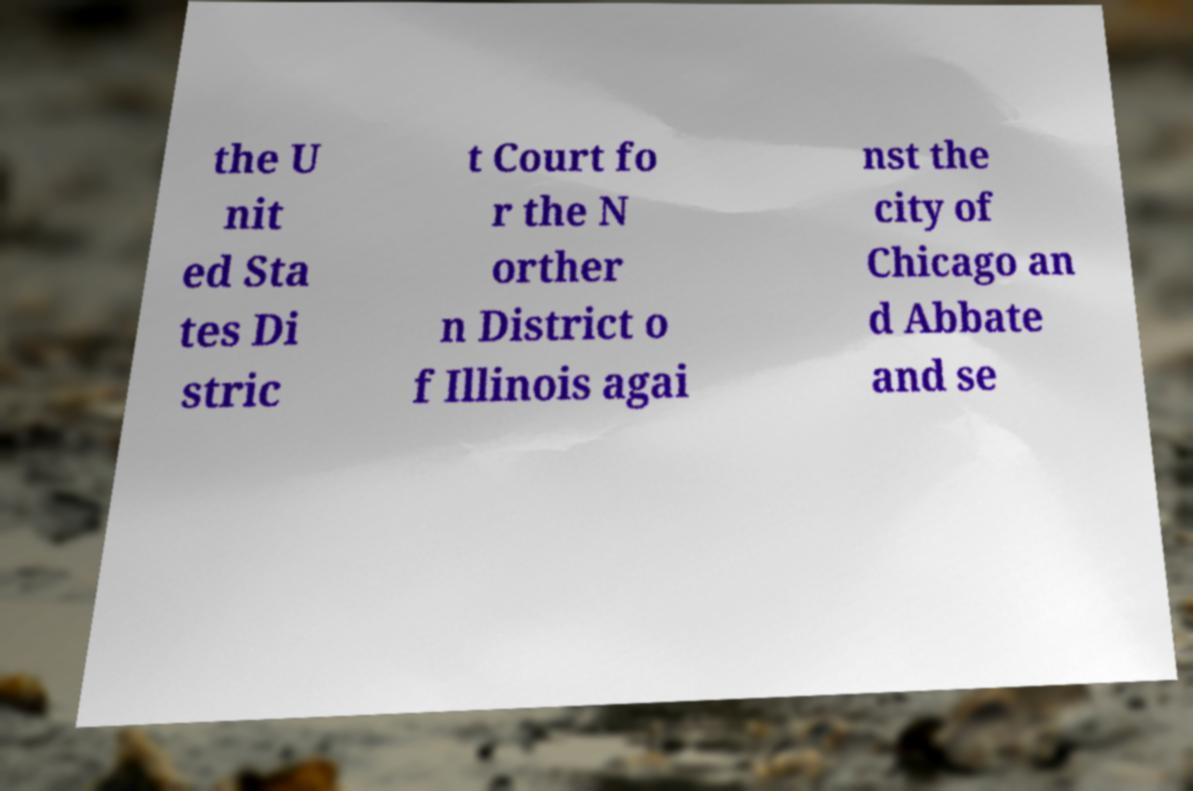I need the written content from this picture converted into text. Can you do that? the U nit ed Sta tes Di stric t Court fo r the N orther n District o f Illinois agai nst the city of Chicago an d Abbate and se 